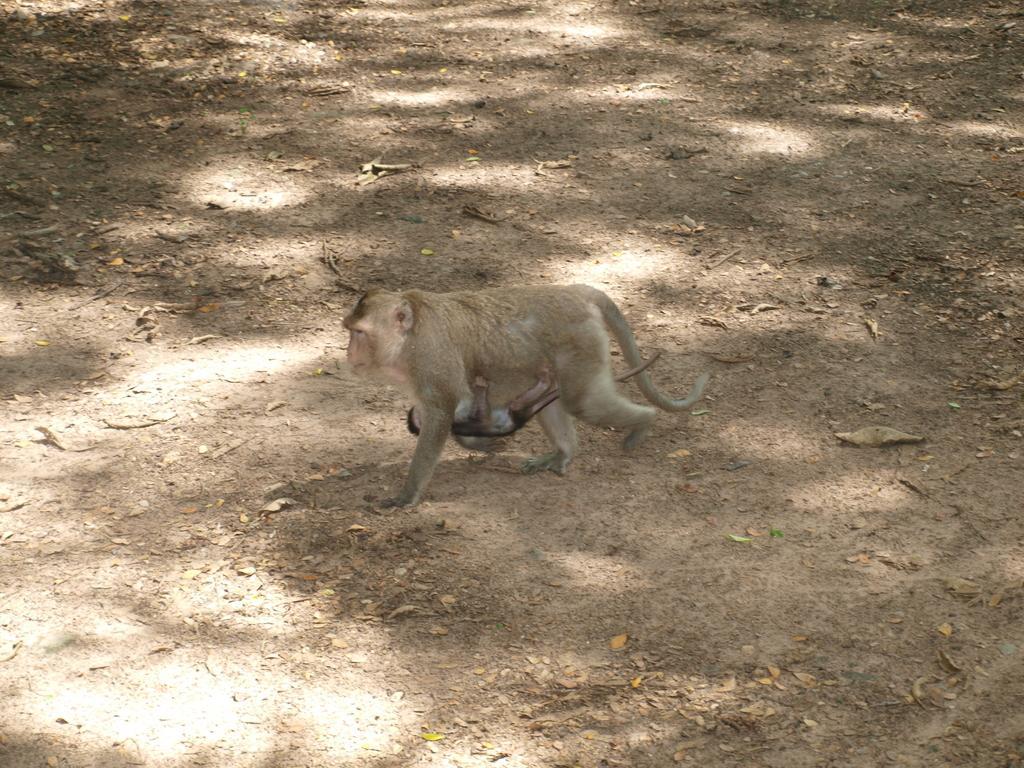Describe this image in one or two sentences. In the image in the center, we can see one monkey, holding a baby monkey. 